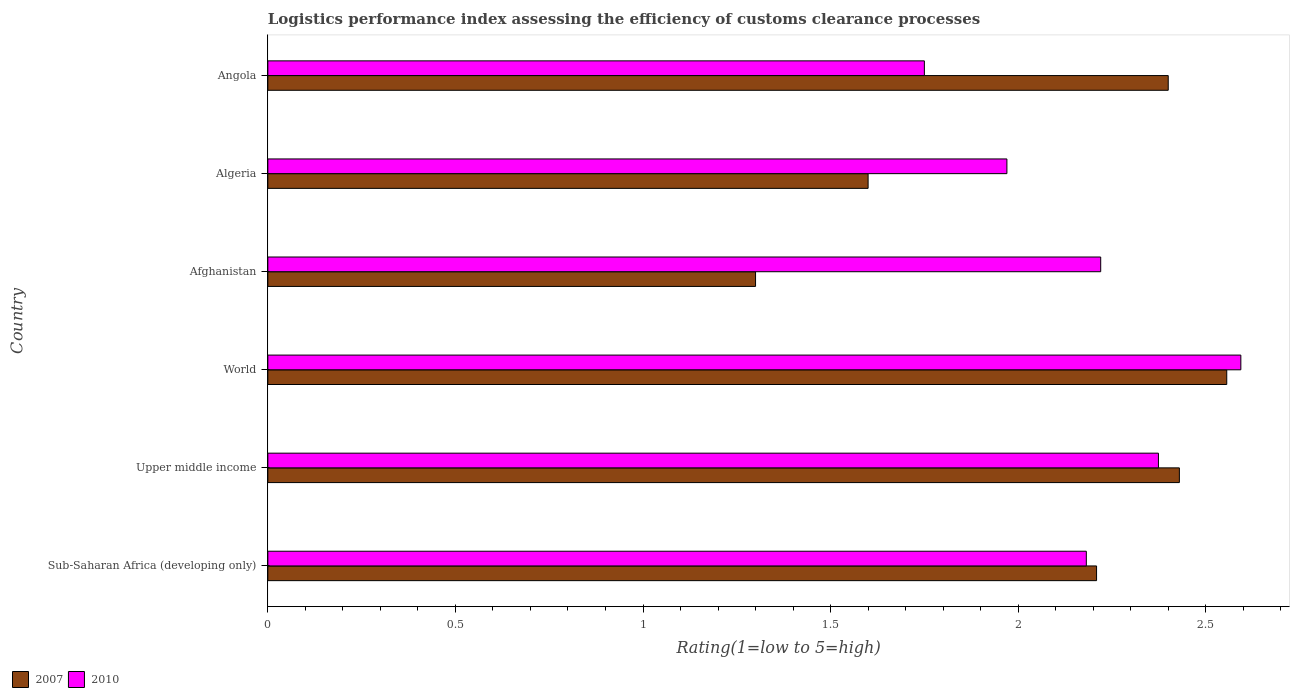How many groups of bars are there?
Ensure brevity in your answer.  6. How many bars are there on the 2nd tick from the top?
Offer a very short reply. 2. How many bars are there on the 4th tick from the bottom?
Your response must be concise. 2. What is the label of the 1st group of bars from the top?
Ensure brevity in your answer.  Angola. What is the Logistic performance index in 2007 in World?
Keep it short and to the point. 2.56. Across all countries, what is the maximum Logistic performance index in 2010?
Make the answer very short. 2.59. Across all countries, what is the minimum Logistic performance index in 2010?
Ensure brevity in your answer.  1.75. In which country was the Logistic performance index in 2007 maximum?
Offer a terse response. World. In which country was the Logistic performance index in 2010 minimum?
Your answer should be very brief. Angola. What is the total Logistic performance index in 2010 in the graph?
Give a very brief answer. 13.09. What is the difference between the Logistic performance index in 2007 in Algeria and that in Sub-Saharan Africa (developing only)?
Give a very brief answer. -0.61. What is the difference between the Logistic performance index in 2007 in Upper middle income and the Logistic performance index in 2010 in Afghanistan?
Provide a short and direct response. 0.21. What is the average Logistic performance index in 2007 per country?
Give a very brief answer. 2.08. What is the difference between the Logistic performance index in 2007 and Logistic performance index in 2010 in Algeria?
Keep it short and to the point. -0.37. In how many countries, is the Logistic performance index in 2010 greater than 1.6 ?
Give a very brief answer. 6. What is the ratio of the Logistic performance index in 2007 in Algeria to that in World?
Provide a short and direct response. 0.63. Is the Logistic performance index in 2010 in Angola less than that in Upper middle income?
Offer a terse response. Yes. Is the difference between the Logistic performance index in 2007 in Afghanistan and Angola greater than the difference between the Logistic performance index in 2010 in Afghanistan and Angola?
Keep it short and to the point. No. What is the difference between the highest and the second highest Logistic performance index in 2010?
Give a very brief answer. 0.22. What is the difference between the highest and the lowest Logistic performance index in 2010?
Your answer should be compact. 0.84. In how many countries, is the Logistic performance index in 2007 greater than the average Logistic performance index in 2007 taken over all countries?
Provide a succinct answer. 4. What does the 1st bar from the top in Afghanistan represents?
Ensure brevity in your answer.  2010. What does the 1st bar from the bottom in World represents?
Keep it short and to the point. 2007. Are all the bars in the graph horizontal?
Provide a short and direct response. Yes. How many countries are there in the graph?
Provide a succinct answer. 6. Where does the legend appear in the graph?
Offer a very short reply. Bottom left. What is the title of the graph?
Provide a succinct answer. Logistics performance index assessing the efficiency of customs clearance processes. Does "2015" appear as one of the legend labels in the graph?
Keep it short and to the point. No. What is the label or title of the X-axis?
Make the answer very short. Rating(1=low to 5=high). What is the label or title of the Y-axis?
Keep it short and to the point. Country. What is the Rating(1=low to 5=high) in 2007 in Sub-Saharan Africa (developing only)?
Provide a short and direct response. 2.21. What is the Rating(1=low to 5=high) in 2010 in Sub-Saharan Africa (developing only)?
Make the answer very short. 2.18. What is the Rating(1=low to 5=high) of 2007 in Upper middle income?
Your response must be concise. 2.43. What is the Rating(1=low to 5=high) in 2010 in Upper middle income?
Your answer should be very brief. 2.37. What is the Rating(1=low to 5=high) of 2007 in World?
Your response must be concise. 2.56. What is the Rating(1=low to 5=high) in 2010 in World?
Your answer should be very brief. 2.59. What is the Rating(1=low to 5=high) in 2010 in Afghanistan?
Ensure brevity in your answer.  2.22. What is the Rating(1=low to 5=high) in 2007 in Algeria?
Provide a short and direct response. 1.6. What is the Rating(1=low to 5=high) of 2010 in Algeria?
Your answer should be compact. 1.97. What is the Rating(1=low to 5=high) of 2010 in Angola?
Provide a short and direct response. 1.75. Across all countries, what is the maximum Rating(1=low to 5=high) in 2007?
Your response must be concise. 2.56. Across all countries, what is the maximum Rating(1=low to 5=high) of 2010?
Provide a short and direct response. 2.59. What is the total Rating(1=low to 5=high) in 2007 in the graph?
Keep it short and to the point. 12.49. What is the total Rating(1=low to 5=high) of 2010 in the graph?
Offer a very short reply. 13.09. What is the difference between the Rating(1=low to 5=high) in 2007 in Sub-Saharan Africa (developing only) and that in Upper middle income?
Ensure brevity in your answer.  -0.22. What is the difference between the Rating(1=low to 5=high) in 2010 in Sub-Saharan Africa (developing only) and that in Upper middle income?
Make the answer very short. -0.19. What is the difference between the Rating(1=low to 5=high) in 2007 in Sub-Saharan Africa (developing only) and that in World?
Keep it short and to the point. -0.35. What is the difference between the Rating(1=low to 5=high) in 2010 in Sub-Saharan Africa (developing only) and that in World?
Provide a succinct answer. -0.41. What is the difference between the Rating(1=low to 5=high) in 2007 in Sub-Saharan Africa (developing only) and that in Afghanistan?
Offer a very short reply. 0.91. What is the difference between the Rating(1=low to 5=high) in 2010 in Sub-Saharan Africa (developing only) and that in Afghanistan?
Offer a terse response. -0.04. What is the difference between the Rating(1=low to 5=high) in 2007 in Sub-Saharan Africa (developing only) and that in Algeria?
Make the answer very short. 0.61. What is the difference between the Rating(1=low to 5=high) in 2010 in Sub-Saharan Africa (developing only) and that in Algeria?
Make the answer very short. 0.21. What is the difference between the Rating(1=low to 5=high) of 2007 in Sub-Saharan Africa (developing only) and that in Angola?
Ensure brevity in your answer.  -0.19. What is the difference between the Rating(1=low to 5=high) in 2010 in Sub-Saharan Africa (developing only) and that in Angola?
Offer a terse response. 0.43. What is the difference between the Rating(1=low to 5=high) in 2007 in Upper middle income and that in World?
Provide a short and direct response. -0.13. What is the difference between the Rating(1=low to 5=high) of 2010 in Upper middle income and that in World?
Provide a short and direct response. -0.22. What is the difference between the Rating(1=low to 5=high) in 2007 in Upper middle income and that in Afghanistan?
Give a very brief answer. 1.13. What is the difference between the Rating(1=low to 5=high) of 2010 in Upper middle income and that in Afghanistan?
Your response must be concise. 0.15. What is the difference between the Rating(1=low to 5=high) in 2007 in Upper middle income and that in Algeria?
Offer a very short reply. 0.83. What is the difference between the Rating(1=low to 5=high) in 2010 in Upper middle income and that in Algeria?
Your response must be concise. 0.4. What is the difference between the Rating(1=low to 5=high) of 2007 in Upper middle income and that in Angola?
Offer a terse response. 0.03. What is the difference between the Rating(1=low to 5=high) in 2010 in Upper middle income and that in Angola?
Your answer should be very brief. 0.62. What is the difference between the Rating(1=low to 5=high) of 2007 in World and that in Afghanistan?
Keep it short and to the point. 1.26. What is the difference between the Rating(1=low to 5=high) in 2010 in World and that in Afghanistan?
Provide a succinct answer. 0.37. What is the difference between the Rating(1=low to 5=high) of 2007 in World and that in Algeria?
Provide a short and direct response. 0.96. What is the difference between the Rating(1=low to 5=high) in 2010 in World and that in Algeria?
Give a very brief answer. 0.62. What is the difference between the Rating(1=low to 5=high) in 2007 in World and that in Angola?
Your answer should be very brief. 0.16. What is the difference between the Rating(1=low to 5=high) of 2010 in World and that in Angola?
Your answer should be compact. 0.84. What is the difference between the Rating(1=low to 5=high) in 2007 in Afghanistan and that in Algeria?
Ensure brevity in your answer.  -0.3. What is the difference between the Rating(1=low to 5=high) in 2007 in Afghanistan and that in Angola?
Your answer should be compact. -1.1. What is the difference between the Rating(1=low to 5=high) of 2010 in Afghanistan and that in Angola?
Provide a short and direct response. 0.47. What is the difference between the Rating(1=low to 5=high) of 2007 in Algeria and that in Angola?
Provide a succinct answer. -0.8. What is the difference between the Rating(1=low to 5=high) of 2010 in Algeria and that in Angola?
Ensure brevity in your answer.  0.22. What is the difference between the Rating(1=low to 5=high) of 2007 in Sub-Saharan Africa (developing only) and the Rating(1=low to 5=high) of 2010 in Upper middle income?
Make the answer very short. -0.16. What is the difference between the Rating(1=low to 5=high) in 2007 in Sub-Saharan Africa (developing only) and the Rating(1=low to 5=high) in 2010 in World?
Give a very brief answer. -0.38. What is the difference between the Rating(1=low to 5=high) in 2007 in Sub-Saharan Africa (developing only) and the Rating(1=low to 5=high) in 2010 in Afghanistan?
Give a very brief answer. -0.01. What is the difference between the Rating(1=low to 5=high) of 2007 in Sub-Saharan Africa (developing only) and the Rating(1=low to 5=high) of 2010 in Algeria?
Your answer should be very brief. 0.24. What is the difference between the Rating(1=low to 5=high) in 2007 in Sub-Saharan Africa (developing only) and the Rating(1=low to 5=high) in 2010 in Angola?
Keep it short and to the point. 0.46. What is the difference between the Rating(1=low to 5=high) in 2007 in Upper middle income and the Rating(1=low to 5=high) in 2010 in World?
Ensure brevity in your answer.  -0.16. What is the difference between the Rating(1=low to 5=high) of 2007 in Upper middle income and the Rating(1=low to 5=high) of 2010 in Afghanistan?
Give a very brief answer. 0.21. What is the difference between the Rating(1=low to 5=high) of 2007 in Upper middle income and the Rating(1=low to 5=high) of 2010 in Algeria?
Offer a very short reply. 0.46. What is the difference between the Rating(1=low to 5=high) in 2007 in Upper middle income and the Rating(1=low to 5=high) in 2010 in Angola?
Give a very brief answer. 0.68. What is the difference between the Rating(1=low to 5=high) in 2007 in World and the Rating(1=low to 5=high) in 2010 in Afghanistan?
Your response must be concise. 0.34. What is the difference between the Rating(1=low to 5=high) of 2007 in World and the Rating(1=low to 5=high) of 2010 in Algeria?
Your answer should be very brief. 0.59. What is the difference between the Rating(1=low to 5=high) of 2007 in World and the Rating(1=low to 5=high) of 2010 in Angola?
Offer a very short reply. 0.81. What is the difference between the Rating(1=low to 5=high) of 2007 in Afghanistan and the Rating(1=low to 5=high) of 2010 in Algeria?
Make the answer very short. -0.67. What is the difference between the Rating(1=low to 5=high) in 2007 in Afghanistan and the Rating(1=low to 5=high) in 2010 in Angola?
Your answer should be compact. -0.45. What is the difference between the Rating(1=low to 5=high) of 2007 in Algeria and the Rating(1=low to 5=high) of 2010 in Angola?
Give a very brief answer. -0.15. What is the average Rating(1=low to 5=high) in 2007 per country?
Your response must be concise. 2.08. What is the average Rating(1=low to 5=high) of 2010 per country?
Provide a succinct answer. 2.18. What is the difference between the Rating(1=low to 5=high) of 2007 and Rating(1=low to 5=high) of 2010 in Sub-Saharan Africa (developing only)?
Offer a very short reply. 0.03. What is the difference between the Rating(1=low to 5=high) of 2007 and Rating(1=low to 5=high) of 2010 in Upper middle income?
Your answer should be very brief. 0.06. What is the difference between the Rating(1=low to 5=high) of 2007 and Rating(1=low to 5=high) of 2010 in World?
Provide a succinct answer. -0.04. What is the difference between the Rating(1=low to 5=high) in 2007 and Rating(1=low to 5=high) in 2010 in Afghanistan?
Keep it short and to the point. -0.92. What is the difference between the Rating(1=low to 5=high) in 2007 and Rating(1=low to 5=high) in 2010 in Algeria?
Offer a terse response. -0.37. What is the difference between the Rating(1=low to 5=high) in 2007 and Rating(1=low to 5=high) in 2010 in Angola?
Offer a terse response. 0.65. What is the ratio of the Rating(1=low to 5=high) of 2007 in Sub-Saharan Africa (developing only) to that in Upper middle income?
Provide a short and direct response. 0.91. What is the ratio of the Rating(1=low to 5=high) in 2010 in Sub-Saharan Africa (developing only) to that in Upper middle income?
Your answer should be compact. 0.92. What is the ratio of the Rating(1=low to 5=high) of 2007 in Sub-Saharan Africa (developing only) to that in World?
Provide a succinct answer. 0.86. What is the ratio of the Rating(1=low to 5=high) in 2010 in Sub-Saharan Africa (developing only) to that in World?
Make the answer very short. 0.84. What is the ratio of the Rating(1=low to 5=high) in 2007 in Sub-Saharan Africa (developing only) to that in Afghanistan?
Your answer should be very brief. 1.7. What is the ratio of the Rating(1=low to 5=high) of 2010 in Sub-Saharan Africa (developing only) to that in Afghanistan?
Your response must be concise. 0.98. What is the ratio of the Rating(1=low to 5=high) in 2007 in Sub-Saharan Africa (developing only) to that in Algeria?
Provide a short and direct response. 1.38. What is the ratio of the Rating(1=low to 5=high) in 2010 in Sub-Saharan Africa (developing only) to that in Algeria?
Offer a terse response. 1.11. What is the ratio of the Rating(1=low to 5=high) of 2007 in Sub-Saharan Africa (developing only) to that in Angola?
Your answer should be compact. 0.92. What is the ratio of the Rating(1=low to 5=high) of 2010 in Sub-Saharan Africa (developing only) to that in Angola?
Offer a terse response. 1.25. What is the ratio of the Rating(1=low to 5=high) of 2007 in Upper middle income to that in World?
Your answer should be compact. 0.95. What is the ratio of the Rating(1=low to 5=high) in 2010 in Upper middle income to that in World?
Your answer should be very brief. 0.92. What is the ratio of the Rating(1=low to 5=high) in 2007 in Upper middle income to that in Afghanistan?
Keep it short and to the point. 1.87. What is the ratio of the Rating(1=low to 5=high) in 2010 in Upper middle income to that in Afghanistan?
Make the answer very short. 1.07. What is the ratio of the Rating(1=low to 5=high) of 2007 in Upper middle income to that in Algeria?
Ensure brevity in your answer.  1.52. What is the ratio of the Rating(1=low to 5=high) of 2010 in Upper middle income to that in Algeria?
Provide a succinct answer. 1.21. What is the ratio of the Rating(1=low to 5=high) of 2007 in Upper middle income to that in Angola?
Your answer should be very brief. 1.01. What is the ratio of the Rating(1=low to 5=high) in 2010 in Upper middle income to that in Angola?
Your response must be concise. 1.36. What is the ratio of the Rating(1=low to 5=high) of 2007 in World to that in Afghanistan?
Your response must be concise. 1.97. What is the ratio of the Rating(1=low to 5=high) of 2010 in World to that in Afghanistan?
Make the answer very short. 1.17. What is the ratio of the Rating(1=low to 5=high) of 2007 in World to that in Algeria?
Your response must be concise. 1.6. What is the ratio of the Rating(1=low to 5=high) in 2010 in World to that in Algeria?
Give a very brief answer. 1.32. What is the ratio of the Rating(1=low to 5=high) in 2007 in World to that in Angola?
Offer a terse response. 1.06. What is the ratio of the Rating(1=low to 5=high) of 2010 in World to that in Angola?
Give a very brief answer. 1.48. What is the ratio of the Rating(1=low to 5=high) of 2007 in Afghanistan to that in Algeria?
Your response must be concise. 0.81. What is the ratio of the Rating(1=low to 5=high) of 2010 in Afghanistan to that in Algeria?
Provide a succinct answer. 1.13. What is the ratio of the Rating(1=low to 5=high) of 2007 in Afghanistan to that in Angola?
Offer a terse response. 0.54. What is the ratio of the Rating(1=low to 5=high) in 2010 in Afghanistan to that in Angola?
Keep it short and to the point. 1.27. What is the ratio of the Rating(1=low to 5=high) in 2010 in Algeria to that in Angola?
Your answer should be compact. 1.13. What is the difference between the highest and the second highest Rating(1=low to 5=high) in 2007?
Your answer should be very brief. 0.13. What is the difference between the highest and the second highest Rating(1=low to 5=high) in 2010?
Provide a succinct answer. 0.22. What is the difference between the highest and the lowest Rating(1=low to 5=high) in 2007?
Give a very brief answer. 1.26. What is the difference between the highest and the lowest Rating(1=low to 5=high) of 2010?
Ensure brevity in your answer.  0.84. 